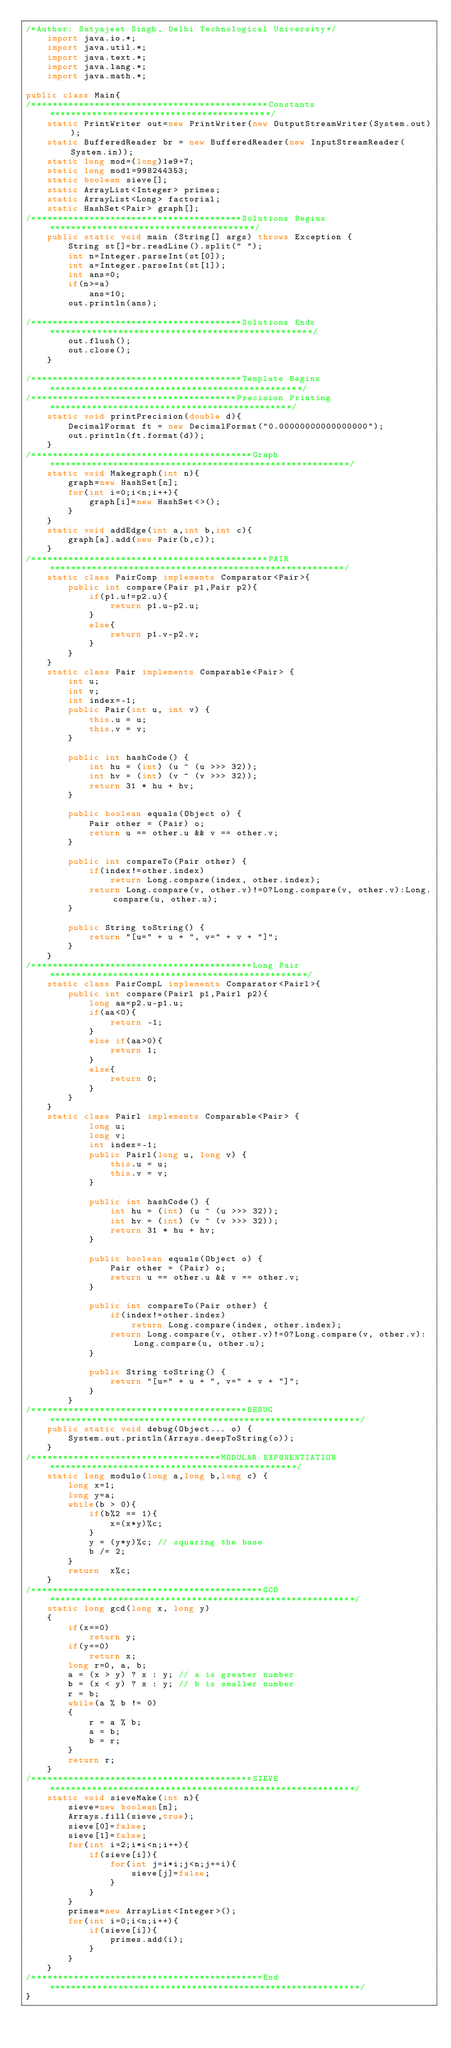<code> <loc_0><loc_0><loc_500><loc_500><_Java_>/*Author: Satyajeet Singh, Delhi Technological University*/
    import java.io.*;
    import java.util.*;
    import java.text.*; 
    import java.lang.*;
    import java.math.*;

public class Main{
/*********************************************Constants******************************************/
    static PrintWriter out=new PrintWriter(new OutputStreamWriter(System.out));        
    static BufferedReader br = new BufferedReader(new InputStreamReader(System.in));
    static long mod=(long)1e9+7;
    static long mod1=998244353;
    static boolean sieve[];
    static ArrayList<Integer> primes;
    static ArrayList<Long> factorial;
    static HashSet<Pair> graph[];
/****************************************Solutions Begins***************************************/
    public static void main (String[] args) throws Exception {
        String st[]=br.readLine().split(" ");
        int n=Integer.parseInt(st[0]);
        int a=Integer.parseInt(st[1]);
        int ans=0;
        if(n>=a)
            ans=10;
        out.println(ans);
        
/****************************************Solutions Ends**************************************************/
        out.flush();
        out.close();
    }

/****************************************Template Begins************************************************/
/***************************************Precision Printing**********************************************/
    static void printPrecision(double d){
        DecimalFormat ft = new DecimalFormat("0.00000000000000000"); 
        out.println(ft.format(d));
    }
/******************************************Graph*********************************************************/
    static void Makegraph(int n){
        graph=new HashSet[n];
        for(int i=0;i<n;i++){
            graph[i]=new HashSet<>();
        }
    }
    static void addEdge(int a,int b,int c){
        graph[a].add(new Pair(b,c));
    }    
/*********************************************PAIR********************************************************/
    static class PairComp implements Comparator<Pair>{
        public int compare(Pair p1,Pair p2){
            if(p1.u!=p2.u){
                return p1.u-p2.u;
            }
            else{
                return p1.v-p2.v;
            }
        }
    }
    static class Pair implements Comparable<Pair> {
        int u;
        int v;
        int index=-1;
        public Pair(int u, int v) {
            this.u = u;
            this.v = v;
        }
 
        public int hashCode() {
            int hu = (int) (u ^ (u >>> 32));
            int hv = (int) (v ^ (v >>> 32));
            return 31 * hu + hv;
        }
 
        public boolean equals(Object o) {
            Pair other = (Pair) o;
            return u == other.u && v == other.v;
        }
 
        public int compareTo(Pair other) {
            if(index!=other.index)
                return Long.compare(index, other.index);
            return Long.compare(v, other.v)!=0?Long.compare(v, other.v):Long.compare(u, other.u);
        }
 
        public String toString() {
            return "[u=" + u + ", v=" + v + "]";
        }
    }
/******************************************Long Pair*************************************************/
    static class PairCompL implements Comparator<Pairl>{
        public int compare(Pairl p1,Pairl p2){
            long aa=p2.u-p1.u;
            if(aa<0){
                return -1;
            }
            else if(aa>0){
                return 1;
            }
            else{
                return 0;
            }
        }
    }
    static class Pairl implements Comparable<Pair> {
            long u;
            long v;
            int index=-1;
            public Pairl(long u, long v) {
                this.u = u;
                this.v = v;
            }
    
            public int hashCode() {
                int hu = (int) (u ^ (u >>> 32));
                int hv = (int) (v ^ (v >>> 32));
                return 31 * hu + hv;
            }
    
            public boolean equals(Object o) {
                Pair other = (Pair) o;
                return u == other.u && v == other.v;
            }
    
            public int compareTo(Pair other) {
                if(index!=other.index)
                    return Long.compare(index, other.index);
                return Long.compare(v, other.v)!=0?Long.compare(v, other.v):Long.compare(u, other.u);
            }
    
            public String toString() {
                return "[u=" + u + ", v=" + v + "]";
            }
        }
/*****************************************DEBUG***********************************************************/
    public static void debug(Object... o) {
        System.out.println(Arrays.deepToString(o));
    }
/************************************MODULAR EXPONENTIATION***********************************************/
    static long modulo(long a,long b,long c) {
        long x=1;
        long y=a;
        while(b > 0){
            if(b%2 == 1){
                x=(x*y)%c;
            }
            y = (y*y)%c; // squaring the base
            b /= 2;
        }
        return  x%c;
    }
/********************************************GCD**********************************************************/
    static long gcd(long x, long y)
    {
        if(x==0)
            return y;
        if(y==0)
            return x;
        long r=0, a, b;
        a = (x > y) ? x : y; // a is greater number
        b = (x < y) ? x : y; // b is smaller number
        r = b;
        while(a % b != 0)
        {
            r = a % b;
            a = b;
            b = r;
        }
        return r;
    }
/******************************************SIEVE**********************************************************/
    static void sieveMake(int n){
        sieve=new boolean[n];
        Arrays.fill(sieve,true);
        sieve[0]=false;
        sieve[1]=false;
        for(int i=2;i*i<n;i++){
            if(sieve[i]){
                for(int j=i*i;j<n;j+=i){
                    sieve[j]=false;
                }
            }
        }
        primes=new ArrayList<Integer>();
        for(int i=0;i<n;i++){
            if(sieve[i]){
                primes.add(i);
            }
        }        
    }
/********************************************End***********************************************************/
}</code> 